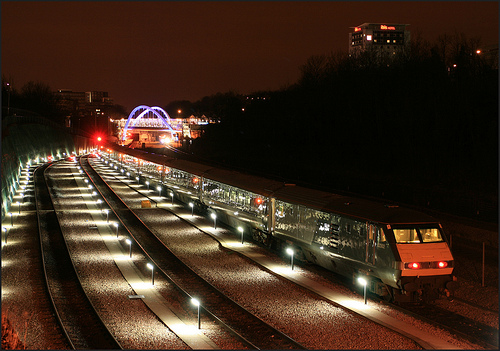What time of day does this photo seem to be taken? The photo appears to be taken at night, as evidenced by the dark sky and artificial lighting along the tracks and nearby structures. 